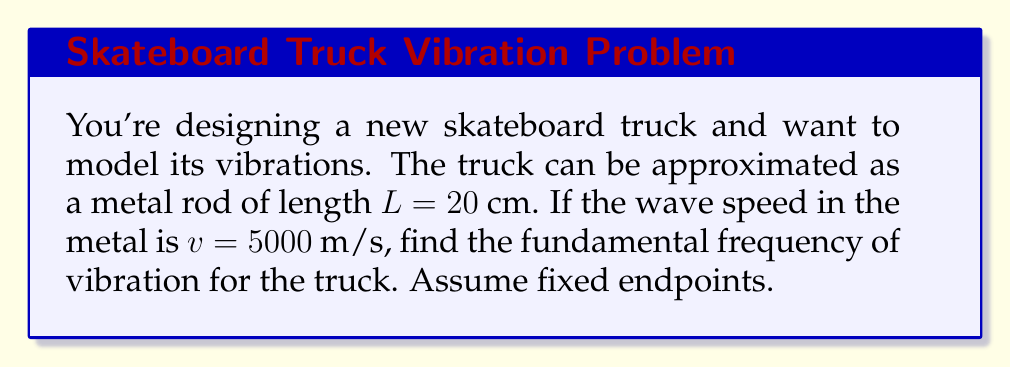Help me with this question. To solve this problem, we'll use the wave equation and the concept of standing waves in a rod with fixed endpoints. Let's break it down step-by-step:

1) For a rod with fixed endpoints, the fundamental mode of vibration has a wavelength $\lambda$ that is twice the length of the rod:

   $\lambda = 2L = 2(0.20\text{ m}) = 0.40\text{ m}$

2) The wave speed $v$ is related to frequency $f$ and wavelength $\lambda$ by the equation:

   $v = f\lambda$

3) Rearranging this equation to solve for frequency:

   $f = \frac{v}{\lambda}$

4) Now we can substitute our known values:

   $f = \frac{5000\text{ m/s}}{0.40\text{ m}}$

5) Calculating the result:

   $f = 12,500\text{ Hz} = 12.5\text{ kHz}$

This frequency represents the fundamental mode of vibration for the skateboard truck.
Answer: $12.5\text{ kHz}$ 